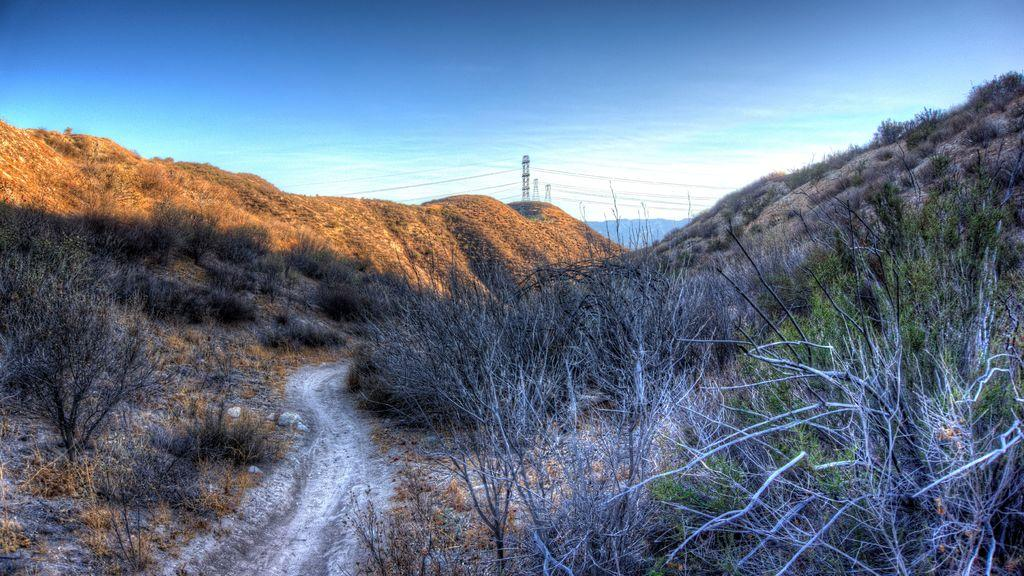What type of vegetation is visible in the front of the image? There are dry plants in the front of the image. What structures can be seen in the background of the image? There are towers in the background of the image. What type of natural landform is visible in the background of the image? There are mountains in the background of the image. What is the condition of the sky in the image? The sky is cloudy in the image. What type of plantation can be seen in the image? There is no plantation present in the image. How many fields are visible in the image? There are no fields visible in the image. 